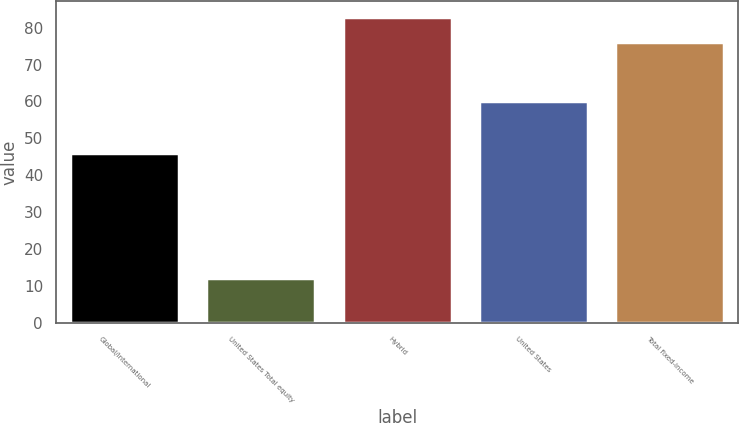Convert chart to OTSL. <chart><loc_0><loc_0><loc_500><loc_500><bar_chart><fcel>Global/international<fcel>United States Total equity<fcel>Hybrid<fcel>United States<fcel>Total fixed-income<nl><fcel>46<fcel>12<fcel>83<fcel>60<fcel>76<nl></chart> 